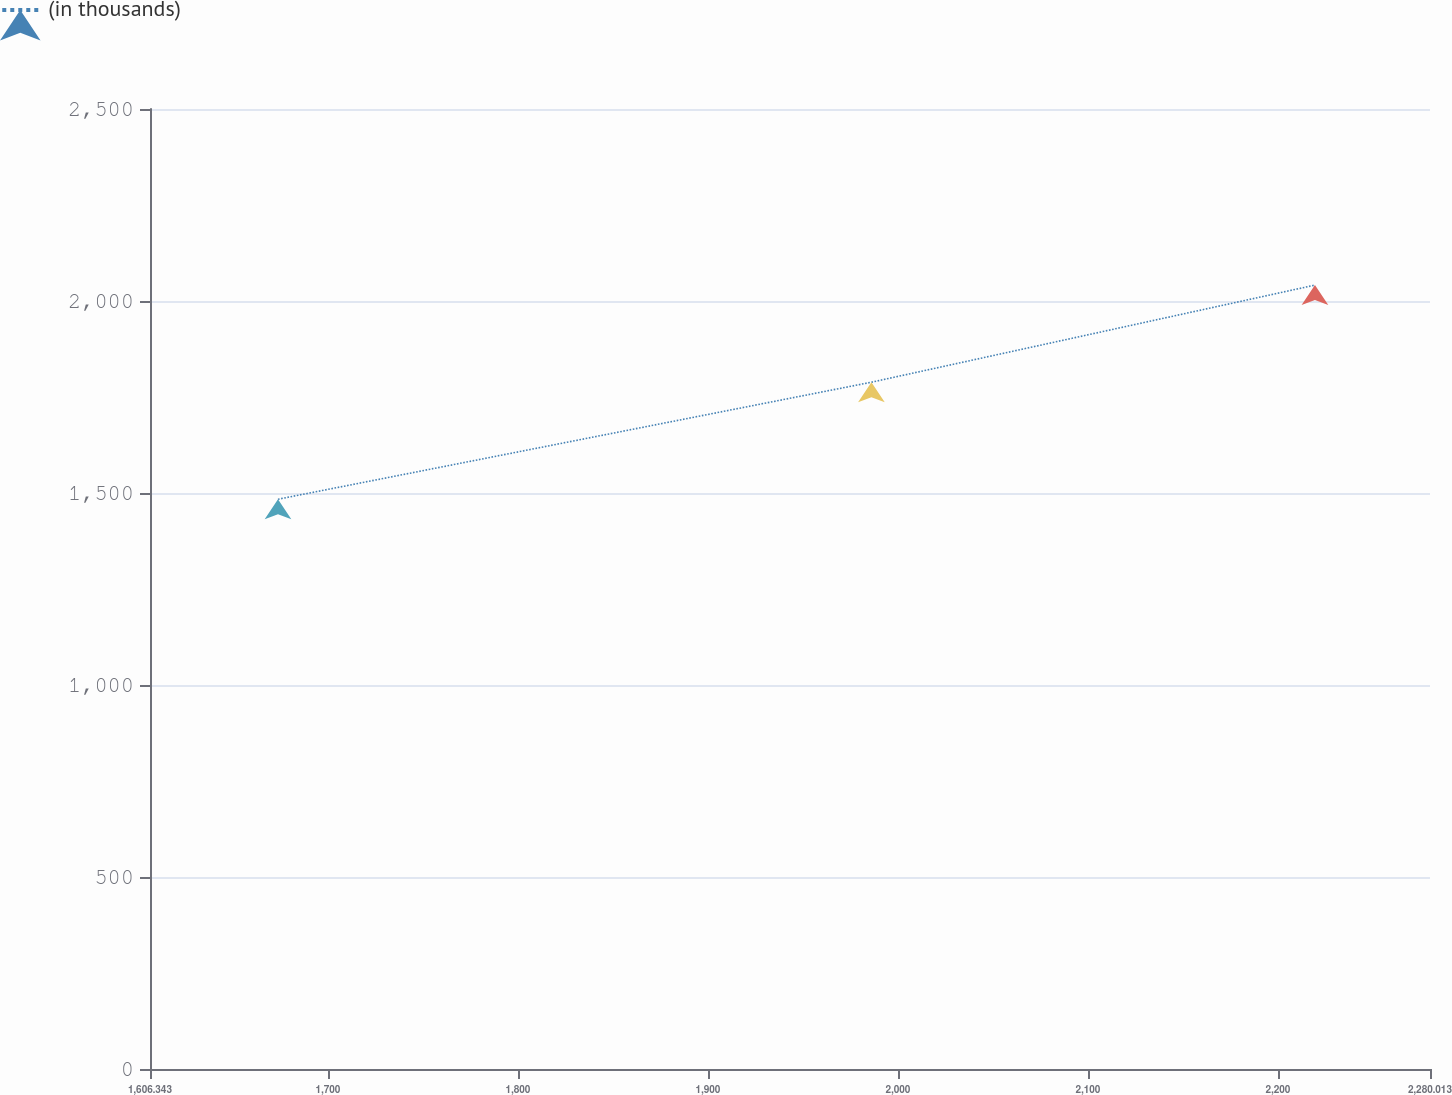Convert chart to OTSL. <chart><loc_0><loc_0><loc_500><loc_500><line_chart><ecel><fcel>(in thousands)<nl><fcel>1673.71<fcel>1483.77<nl><fcel>1986.03<fcel>1788.51<nl><fcel>2219.46<fcel>2041.44<nl><fcel>2283.42<fcel>2099.72<nl><fcel>2347.38<fcel>1846.79<nl></chart> 